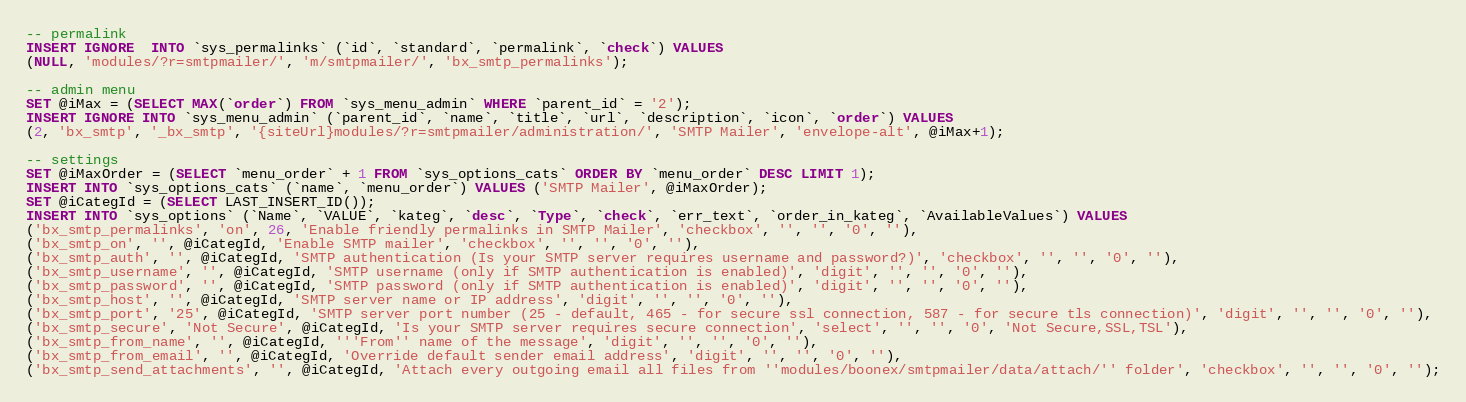Convert code to text. <code><loc_0><loc_0><loc_500><loc_500><_SQL_>
-- permalink
INSERT IGNORE  INTO `sys_permalinks` (`id`, `standard`, `permalink`, `check`) VALUES 
(NULL, 'modules/?r=smtpmailer/', 'm/smtpmailer/', 'bx_smtp_permalinks');

-- admin menu
SET @iMax = (SELECT MAX(`order`) FROM `sys_menu_admin` WHERE `parent_id` = '2');
INSERT IGNORE INTO `sys_menu_admin` (`parent_id`, `name`, `title`, `url`, `description`, `icon`, `order`) VALUES
(2, 'bx_smtp', '_bx_smtp', '{siteUrl}modules/?r=smtpmailer/administration/', 'SMTP Mailer', 'envelope-alt', @iMax+1);

-- settings
SET @iMaxOrder = (SELECT `menu_order` + 1 FROM `sys_options_cats` ORDER BY `menu_order` DESC LIMIT 1);
INSERT INTO `sys_options_cats` (`name`, `menu_order`) VALUES ('SMTP Mailer', @iMaxOrder);
SET @iCategId = (SELECT LAST_INSERT_ID());
INSERT INTO `sys_options` (`Name`, `VALUE`, `kateg`, `desc`, `Type`, `check`, `err_text`, `order_in_kateg`, `AvailableValues`) VALUES
('bx_smtp_permalinks', 'on', 26, 'Enable friendly permalinks in SMTP Mailer', 'checkbox', '', '', '0', ''),
('bx_smtp_on', '', @iCategId, 'Enable SMTP mailer', 'checkbox', '', '', '0', ''),
('bx_smtp_auth', '', @iCategId, 'SMTP authentication (Is your SMTP server requires username and password?)', 'checkbox', '', '', '0', ''),
('bx_smtp_username', '', @iCategId, 'SMTP username (only if SMTP authentication is enabled)', 'digit', '', '', '0', ''),
('bx_smtp_password', '', @iCategId, 'SMTP password (only if SMTP authentication is enabled)', 'digit', '', '', '0', ''),
('bx_smtp_host', '', @iCategId, 'SMTP server name or IP address', 'digit', '', '', '0', ''),
('bx_smtp_port', '25', @iCategId, 'SMTP server port number (25 - default, 465 - for secure ssl connection, 587 - for secure tls connection)', 'digit', '', '', '0', ''),
('bx_smtp_secure', 'Not Secure', @iCategId, 'Is your SMTP server requires secure connection', 'select', '', '', '0', 'Not Secure,SSL,TSL'), 
('bx_smtp_from_name', '', @iCategId, '''From'' name of the message', 'digit', '', '', '0', ''),
('bx_smtp_from_email', '', @iCategId, 'Override default sender email address', 'digit', '', '', '0', ''),
('bx_smtp_send_attachments', '', @iCategId, 'Attach every outgoing email all files from ''modules/boonex/smtpmailer/data/attach/'' folder', 'checkbox', '', '', '0', '');

</code> 